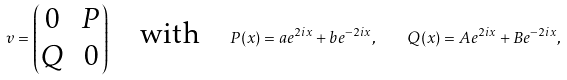Convert formula to latex. <formula><loc_0><loc_0><loc_500><loc_500>v = \begin{pmatrix} 0 & P \\ Q & 0 \end{pmatrix} \quad \text {with} \quad P ( x ) = a e ^ { 2 i x } + b e ^ { - 2 i x } , \quad Q ( x ) = A e ^ { 2 i x } + B e ^ { - 2 i x } ,</formula> 